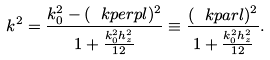Convert formula to latex. <formula><loc_0><loc_0><loc_500><loc_500>k ^ { 2 } = \frac { k _ { 0 } ^ { 2 } - ( \ k p e r p l ) ^ { 2 } } { 1 + \frac { k _ { 0 } ^ { 2 } h _ { z } ^ { 2 } } { 1 2 } } \equiv \frac { ( \ k p a r l ) ^ { 2 } } { 1 + \frac { k _ { 0 } ^ { 2 } h _ { z } ^ { 2 } } { 1 2 } } .</formula> 